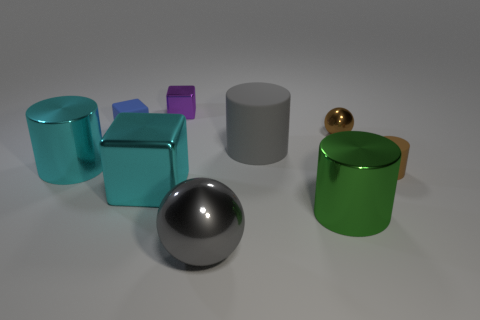How does the lighting in the scene affect the appearance of the objects? The lighting in the scene highlights the reflective properties of the shiny objects and creates soft shadows that give depth to the arrangement. The light source seems to be coming from above, providing a good illumination that accentuates the textures and colors of each object. 